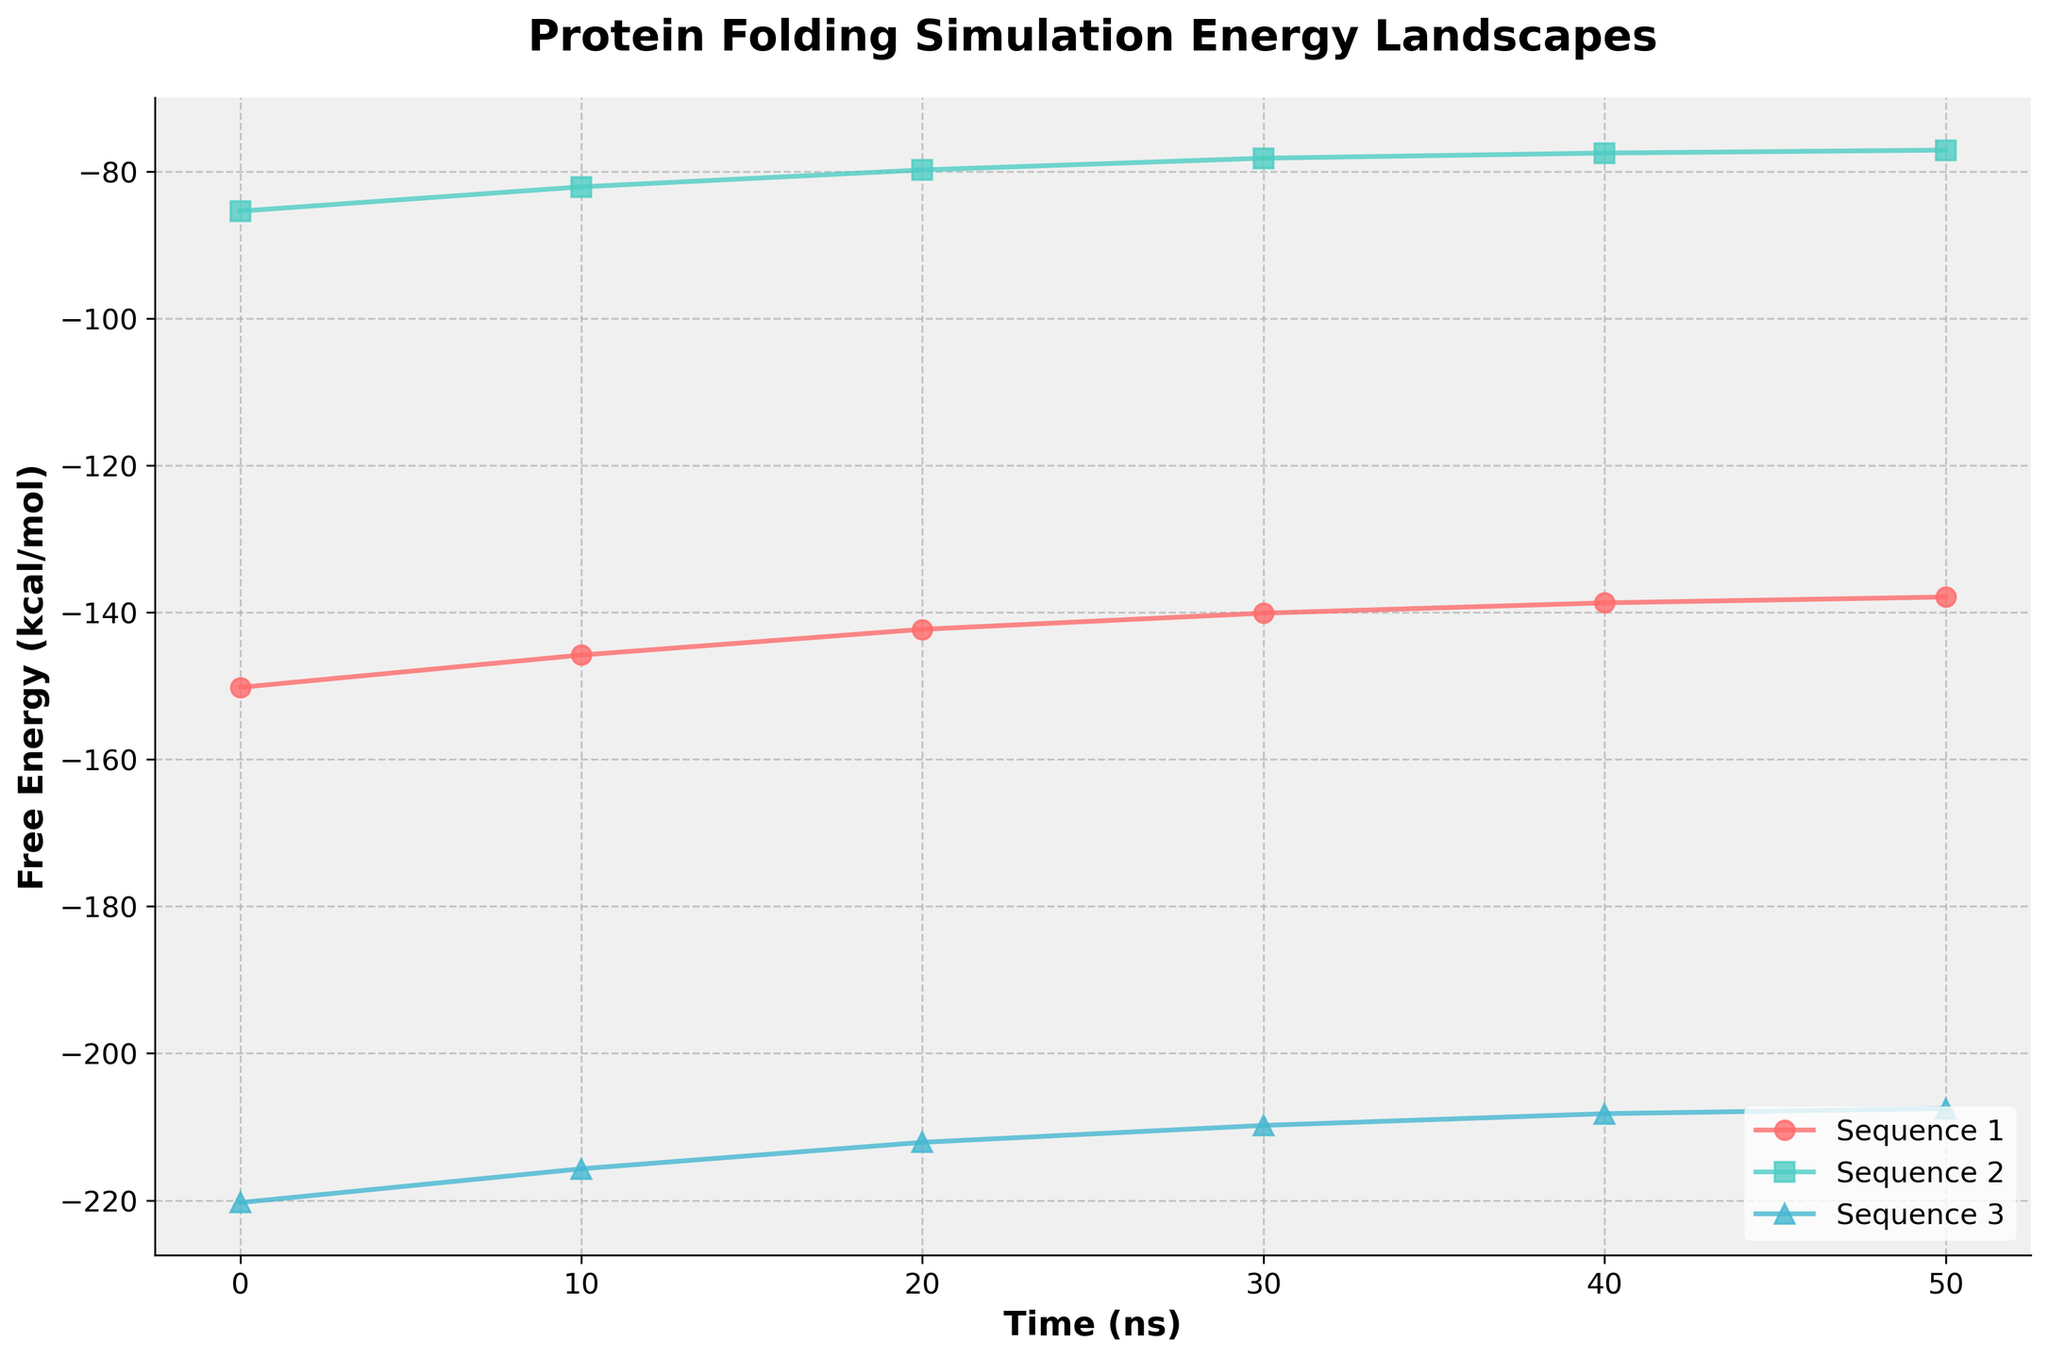What information does the y-axis represent? The y-axis shows the Free Energy (kcal/mol) of protein folding simulations for different amino acid sequences over time.
Answer: Free Energy (kcal/mol) Which sequence has the highest initial free energy? Sequence 3 starts with the highest free energy value at time 0 ns, which is visible as its starting point at -220.3 kcal/mol on the y-axis.
Answer: Sequence 3 How does the free energy of Sequence 1 change from 0 ns to 50 ns? The free energy of Sequence 1 decreases from -150.2 kcal/mol at 0 ns to -137.9 kcal/mol at 50 ns.
Answer: Decreases Which sequence shows the least change in free energy over time? Sequence 2 shows the least change in free energy, starting at -85.4 kcal/mol and ending at -77.1 kcal/mol, a change of 8.3 kcal/mol.
Answer: Sequence 2 Between Sequence 1 and Sequence 3, which one exhibits a greater reduction in free energy by 50 ns? Sequence 3 exhibits a greater reduction: Sequence 1 decreases by 12.3 kcal/mol (-150.2 to -137.9) while Sequence 3 decreases by 12.8 kcal/mol (-220.3 to -207.5).
Answer: Sequence 3 What is the average free energy of Sequence 2 at all time points? Sum the free energy values for Sequence 2 at all time points (-85.4, -82.1, -79.8, -78.2, -77.5, -77.1) and divide by the number of points. The average is (-485.1/6) = -80.85 kcal/mol.
Answer: -80.85 kcal/mol Which sequence has the steepest initial decline in free energy? To determine this, compare the slopes of the lines from 0 ns to 10 ns for each sequence. Sequence 3 has the steepest initial decline (from -220.3 to -215.7, a change of 4.6 kcal/mol).
Answer: Sequence 3 Are there any sequences that show asymptotic behavior in their free energy profiles? Sequence 1 and Sequence 2 both show asymptotic behavior as their free energy values start leveling off between 40 ns and 50 ns.
Answer: Sequence 1 and Sequence 2 How does the free energy of Sequence 3 at 30 ns compare to its free energy at 40 ns? Sequence 3's free energy at 30 ns is -209.8 kcal/mol, whereas at 40 ns, it is -208.2 kcal/mol. This indicates a slight increase in free energy.
Answer: Slight increase 